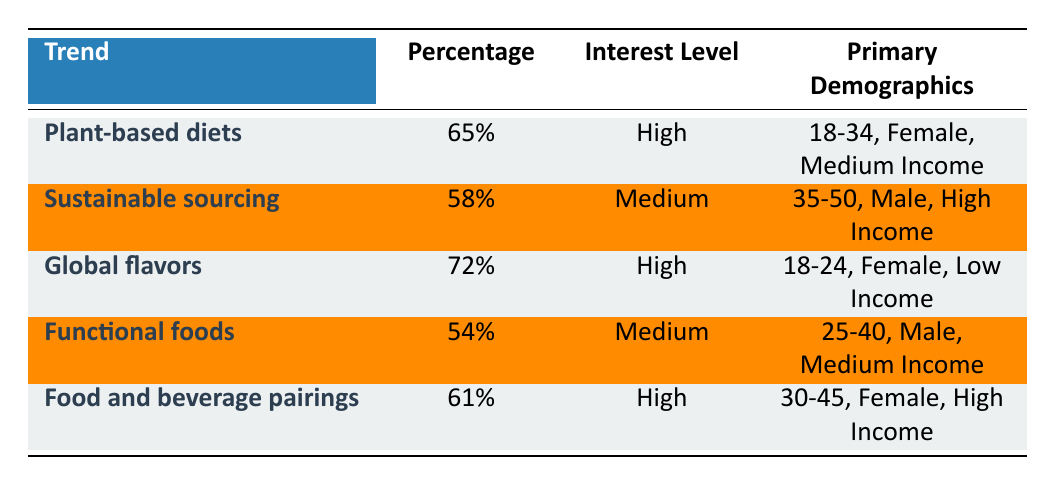What is the trend with the highest percentage of interest? By reviewing the table, the trend "Global flavors" has the highest percentage of 72%.
Answer: Global flavors How many trends have a high interest level? There are three trends marked with "High" interest level: Plant-based diets, Global flavors, and Food and beverage pairings.
Answer: 3 What percentage of attendees are interested in functional foods? The table specifies that the percentage of attendees interested in functional foods is 54%.
Answer: 54% True or False: More than half of attendees are interested in sustainable sourcing. The table lists 58% for sustainable sourcing, which is indeed more than half.
Answer: True What is the average percentage of interest for the trends with a high interest level? The trends with high interest level are: 65% (Plant-based diets), 72% (Global flavors), and 61% (Food and beverage pairings). Adding these gives 65 + 72 + 61 = 198. Dividing by 3 gives an average of 198 / 3 = 66.
Answer: 66 How does the interest level of food and beverage pairings compare to functional foods? Food and beverage pairings has a high interest level while functional foods has a medium interest level, showing that the former has a greater interest.
Answer: Food and beverage pairings is higher What is the primary demographic for the trend "Sustainable sourcing"? The demographic information for sustainable sourcing indicates that it primarily attracts males aged 35-50 with high income.
Answer: Males aged 35-50, High Income Which age group shows the most interest in plant-based diets? According to the table, the age group showing the most interest in plant-based diets is 18-34.
Answer: 18-34 Which trend has the lowest percentage of interest and what is its percentage? The trend "Functional foods" has the lowest percentage of interest at 54%.
Answer: Functional foods, 54% 